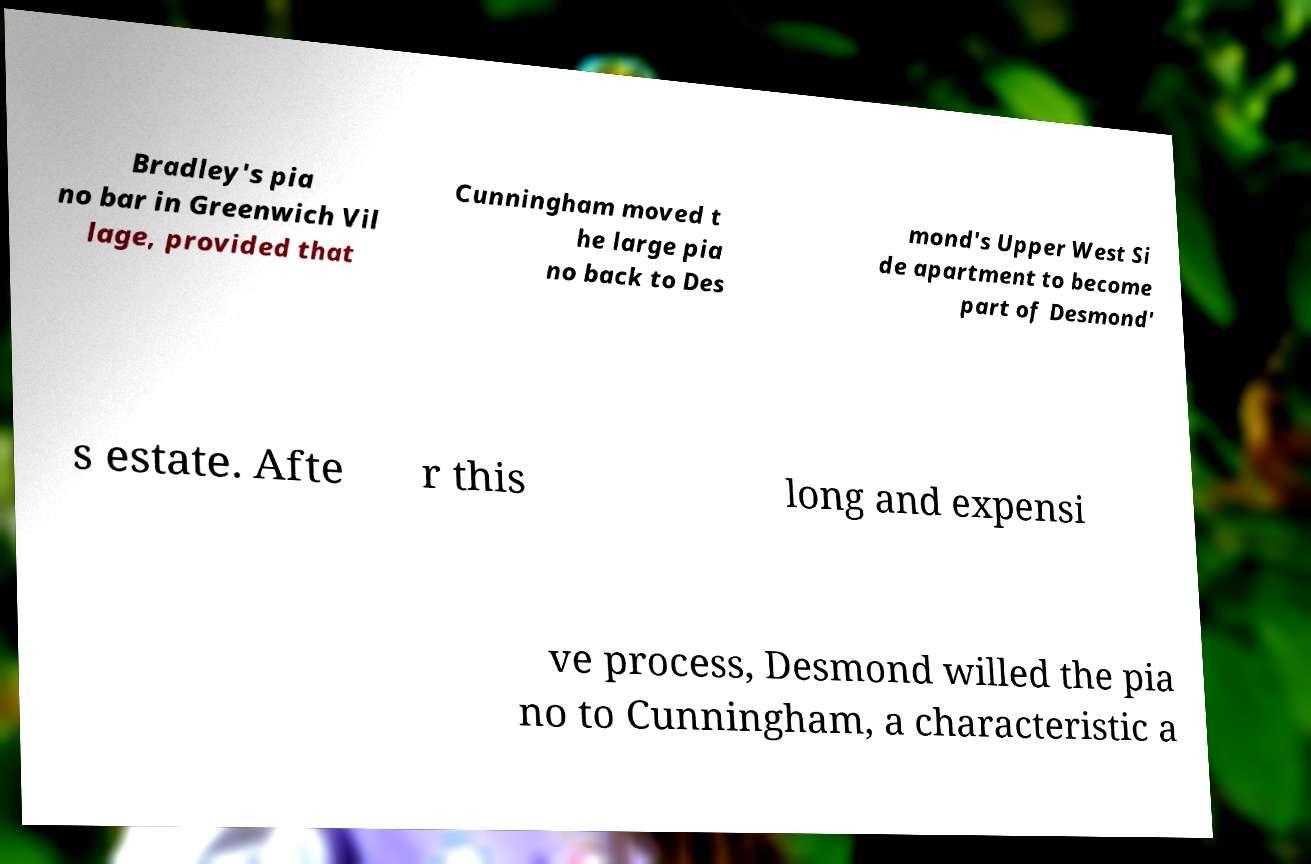Can you read and provide the text displayed in the image?This photo seems to have some interesting text. Can you extract and type it out for me? Bradley's pia no bar in Greenwich Vil lage, provided that Cunningham moved t he large pia no back to Des mond's Upper West Si de apartment to become part of Desmond' s estate. Afte r this long and expensi ve process, Desmond willed the pia no to Cunningham, a characteristic a 